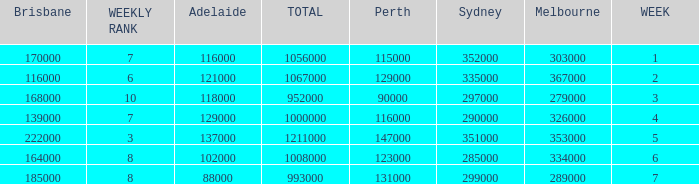How many viewers were there in Sydney for the episode when there were 334000 in Melbourne? 285000.0. 